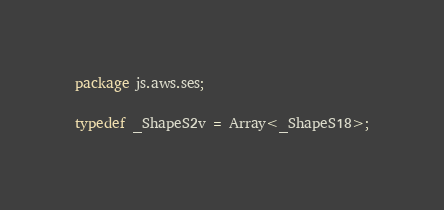<code> <loc_0><loc_0><loc_500><loc_500><_Haxe_>package js.aws.ses;

typedef _ShapeS2v = Array<_ShapeS18>;
</code> 